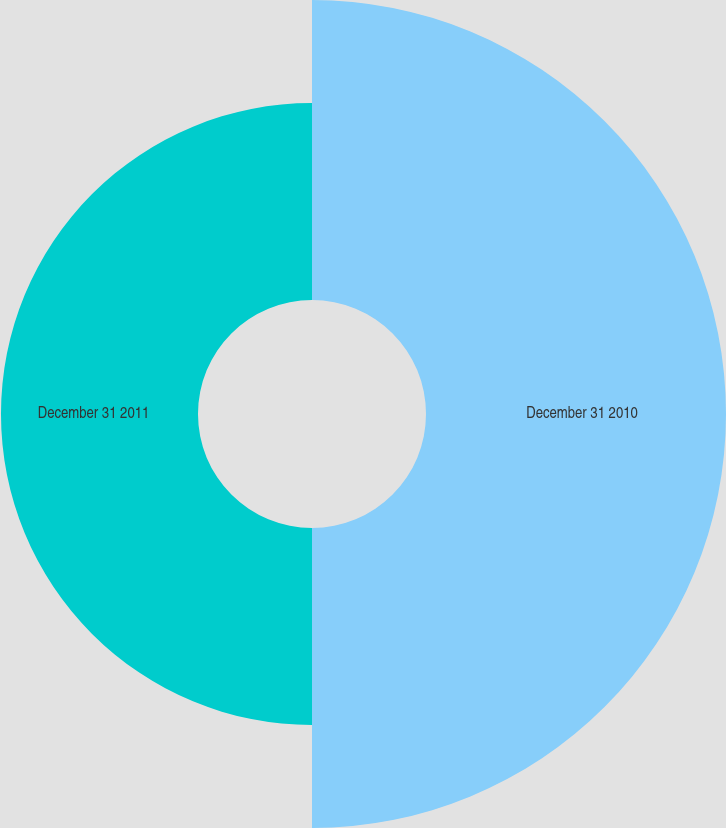Convert chart to OTSL. <chart><loc_0><loc_0><loc_500><loc_500><pie_chart><fcel>December 31 2010<fcel>December 31 2011<nl><fcel>60.36%<fcel>39.64%<nl></chart> 